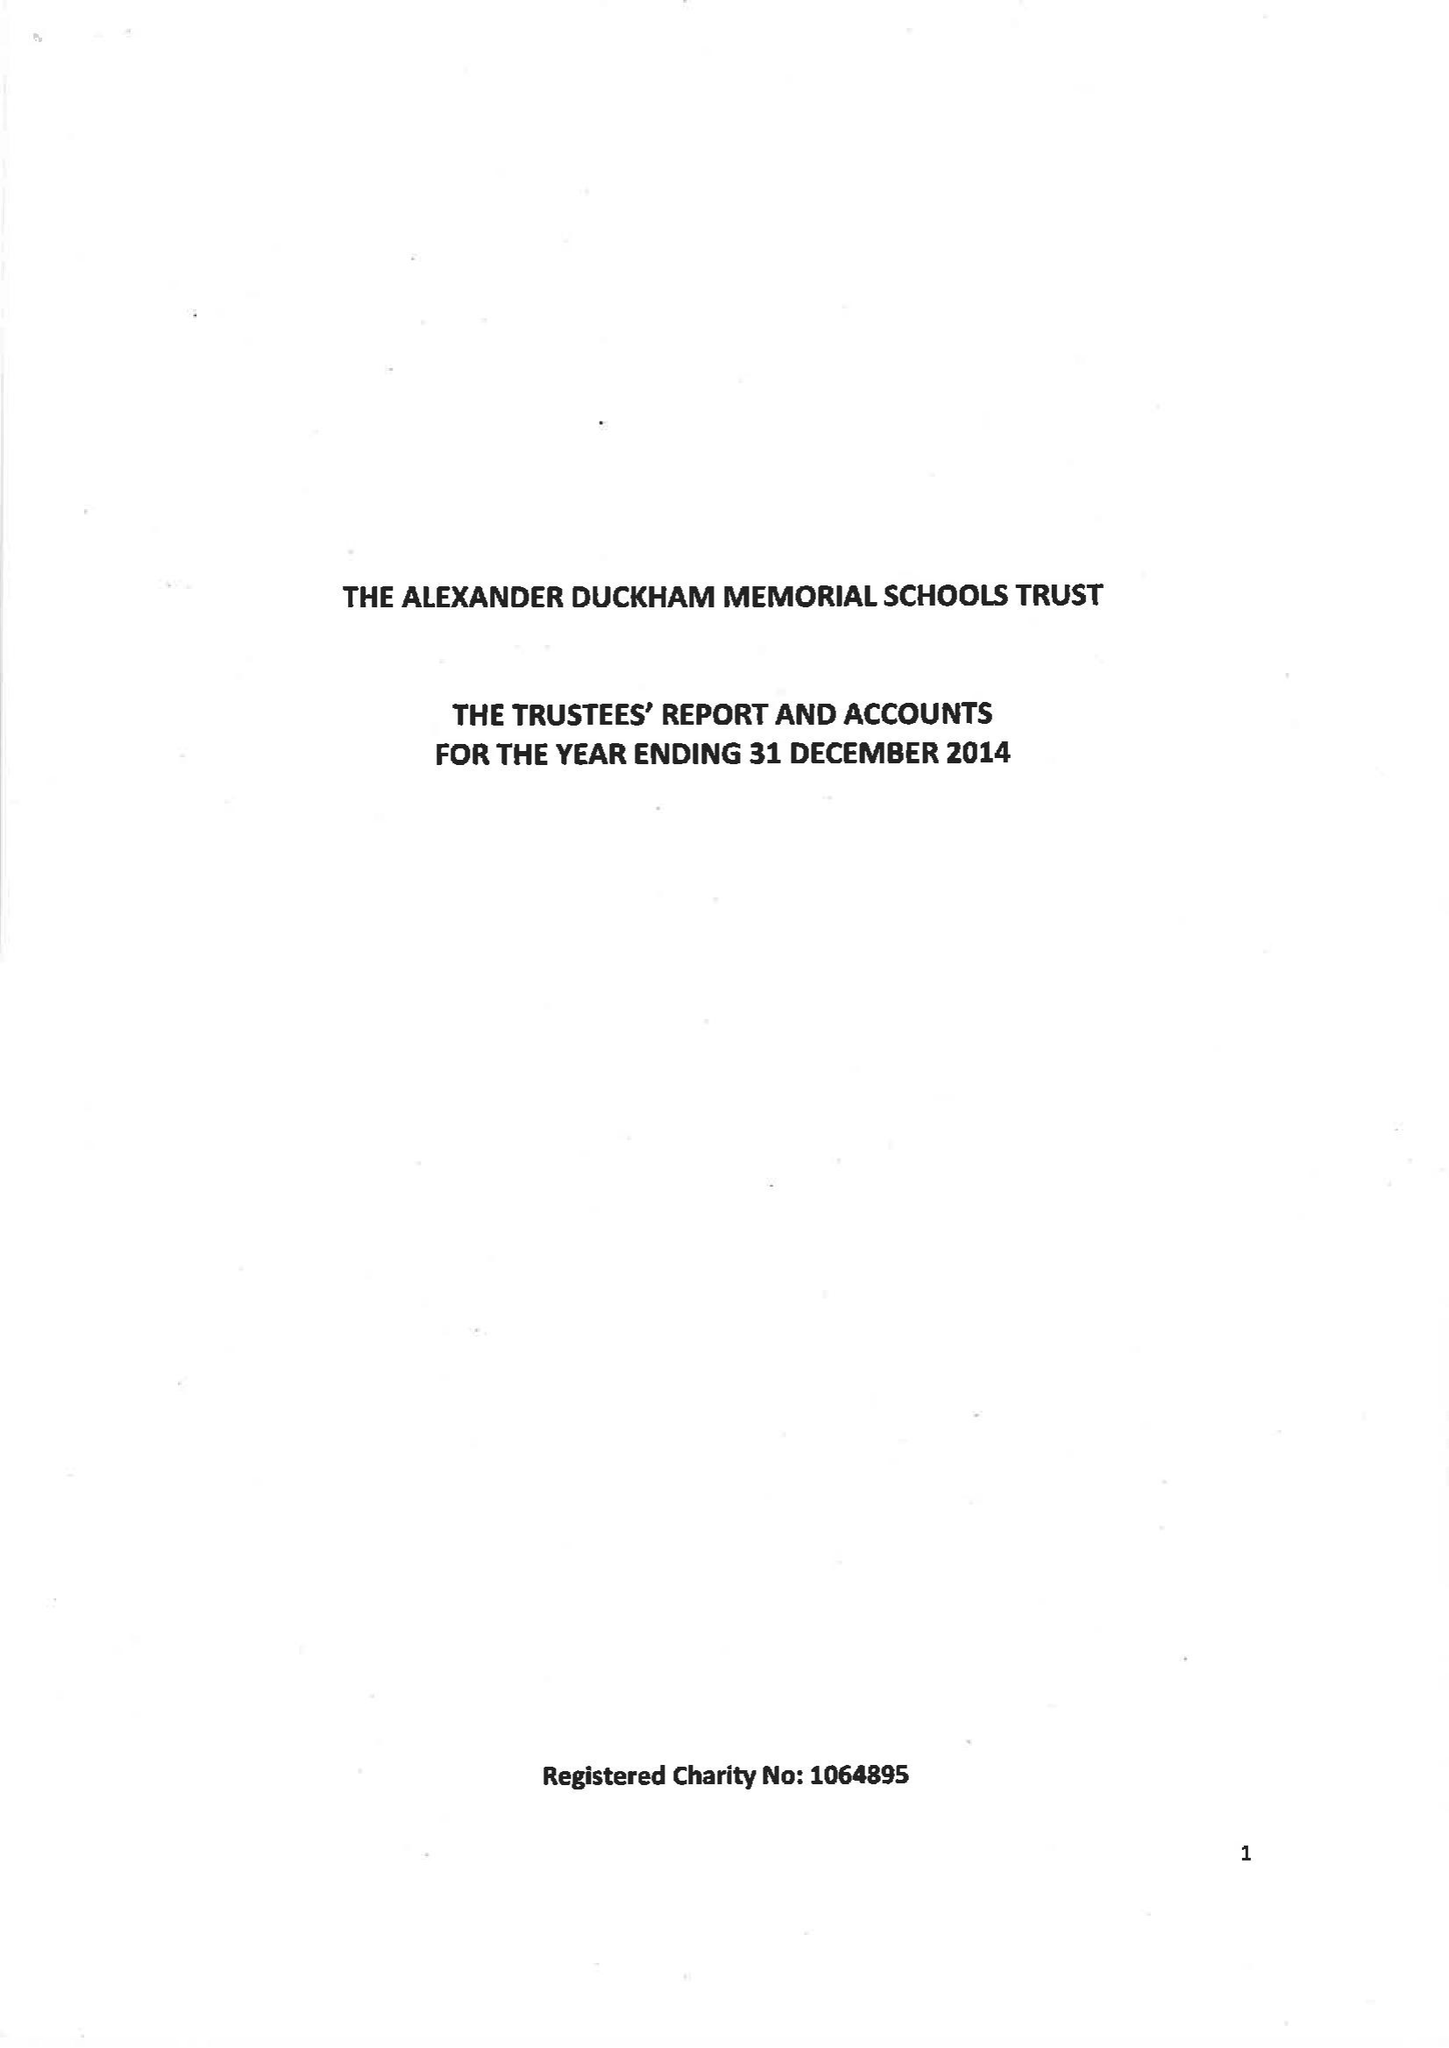What is the value for the address__street_line?
Answer the question using a single word or phrase. None 